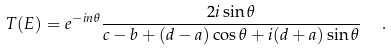Convert formula to latex. <formula><loc_0><loc_0><loc_500><loc_500>T ( E ) = e ^ { - i n \theta } \frac { 2 i \sin \theta } { c - b + ( d - a ) \cos \theta + i ( d + a ) \sin \theta } \ \ .</formula> 